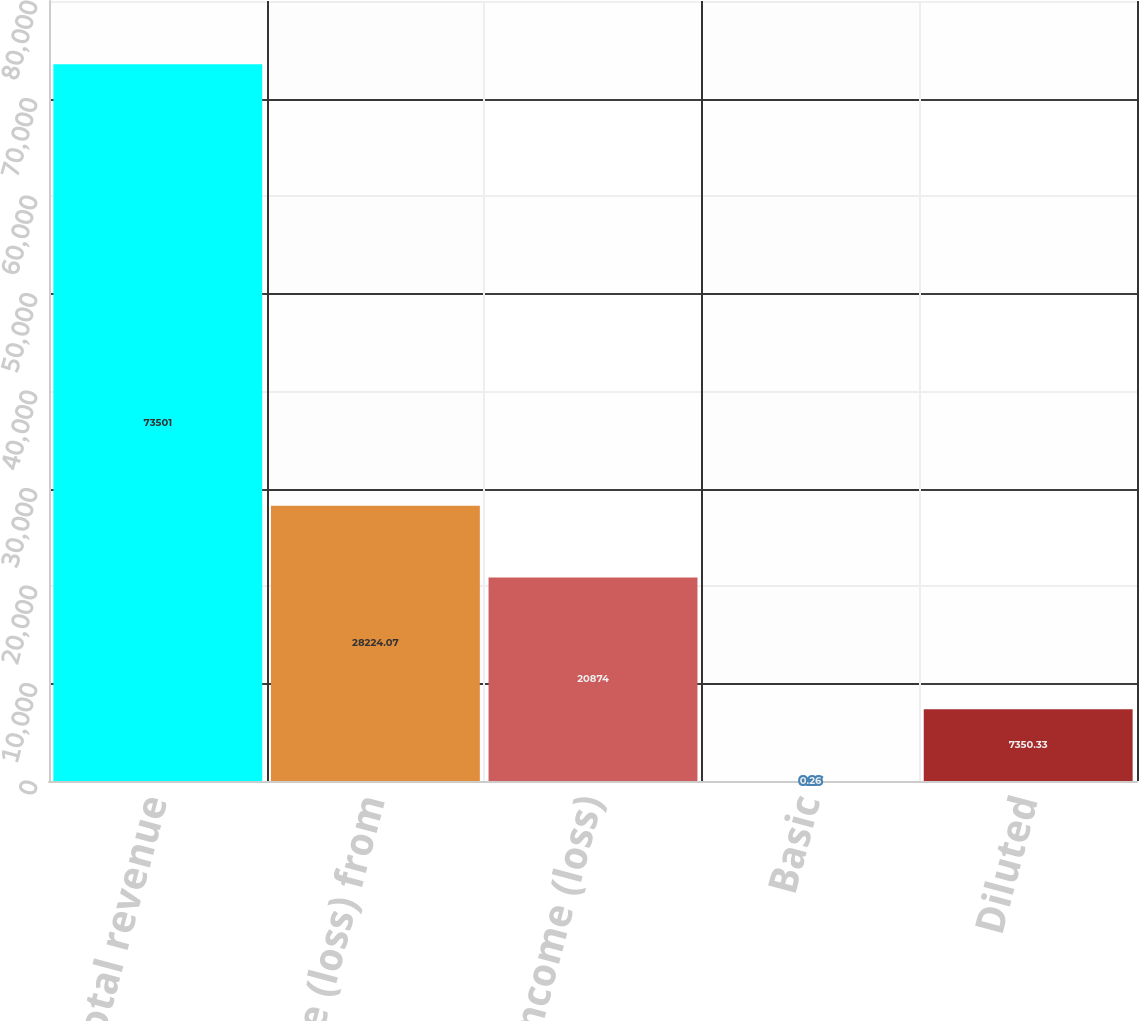Convert chart. <chart><loc_0><loc_0><loc_500><loc_500><bar_chart><fcel>Total revenue<fcel>Income (loss) from<fcel>Net income (loss)<fcel>Basic<fcel>Diluted<nl><fcel>73501<fcel>28224.1<fcel>20874<fcel>0.26<fcel>7350.33<nl></chart> 